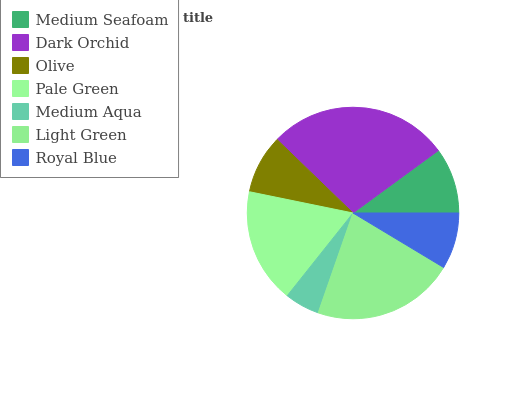Is Medium Aqua the minimum?
Answer yes or no. Yes. Is Dark Orchid the maximum?
Answer yes or no. Yes. Is Olive the minimum?
Answer yes or no. No. Is Olive the maximum?
Answer yes or no. No. Is Dark Orchid greater than Olive?
Answer yes or no. Yes. Is Olive less than Dark Orchid?
Answer yes or no. Yes. Is Olive greater than Dark Orchid?
Answer yes or no. No. Is Dark Orchid less than Olive?
Answer yes or no. No. Is Medium Seafoam the high median?
Answer yes or no. Yes. Is Medium Seafoam the low median?
Answer yes or no. Yes. Is Medium Aqua the high median?
Answer yes or no. No. Is Pale Green the low median?
Answer yes or no. No. 